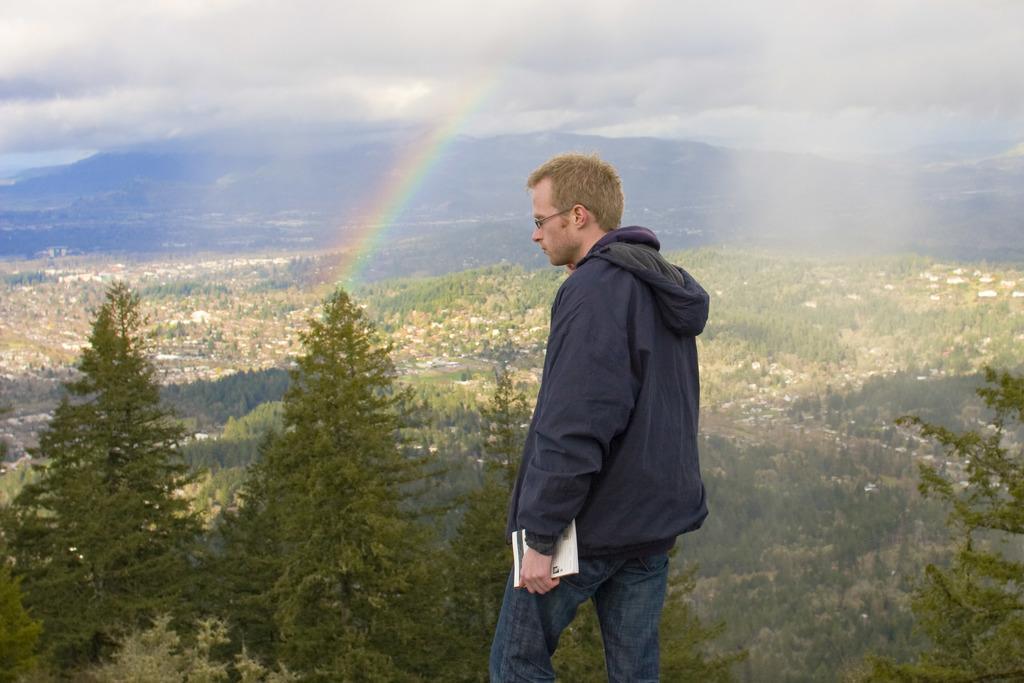Please provide a concise description of this image. In this picture there is a man standing and holding the book. At the back there are mountains and trees and their might be houses. At the top there is sky and there are clouds and there is a rainbow. 